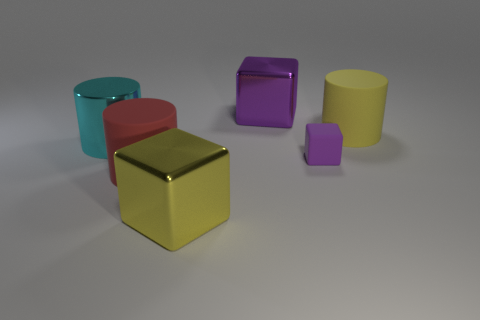There is a big red rubber thing; does it have the same shape as the yellow thing behind the large cyan cylinder?
Offer a terse response. Yes. There is a block that is left of the metal cube that is behind the cyan metallic cylinder; what is it made of?
Your answer should be compact. Metal. Are there an equal number of red matte cylinders that are to the left of the red matte object and tiny blue blocks?
Your response must be concise. Yes. There is a block behind the big yellow cylinder; is its color the same as the matte block to the right of the red cylinder?
Offer a very short reply. Yes. What number of big cylinders are on the left side of the small block and behind the red matte thing?
Make the answer very short. 1. Are there more cubes in front of the large metallic cylinder than rubber blocks?
Give a very brief answer. Yes. There is a large rubber cylinder that is in front of the tiny matte cube; what color is it?
Give a very brief answer. Red. There is a block that is the same color as the tiny rubber object; what size is it?
Make the answer very short. Large. What number of matte objects are cylinders or big purple balls?
Your answer should be compact. 2. Are there any small purple rubber objects in front of the big rubber cylinder to the left of the object right of the purple matte object?
Ensure brevity in your answer.  No. 